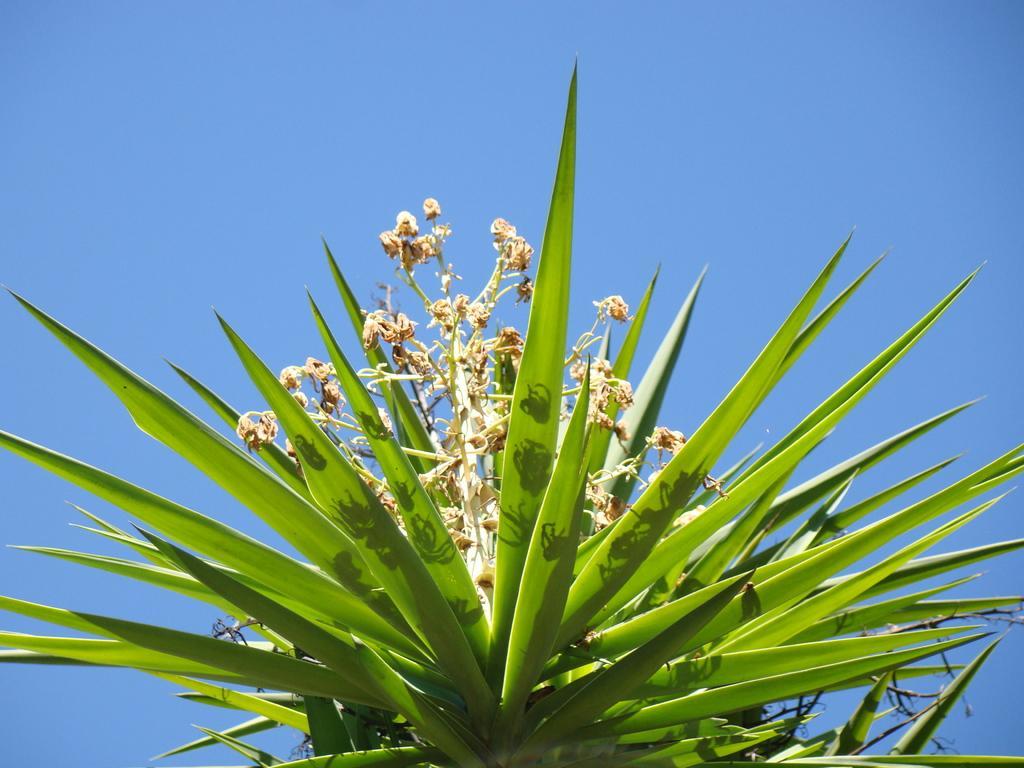In one or two sentences, can you explain what this image depicts? In this image we can see there is a plant with flowers on it. In the background there is the sky. 